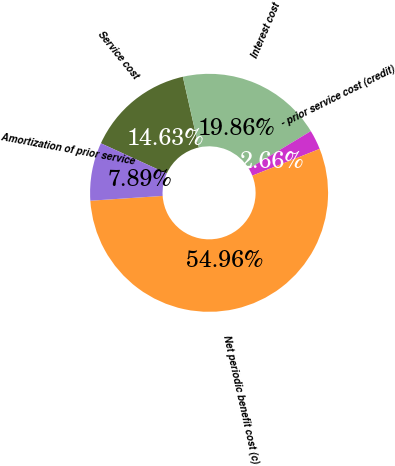Convert chart. <chart><loc_0><loc_0><loc_500><loc_500><pie_chart><fcel>Service cost<fcel>Interest cost<fcel>- prior service cost (credit)<fcel>Net periodic benefit cost (c)<fcel>Amortization of prior service<nl><fcel>14.63%<fcel>19.86%<fcel>2.66%<fcel>54.96%<fcel>7.89%<nl></chart> 